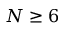Convert formula to latex. <formula><loc_0><loc_0><loc_500><loc_500>N \geq 6</formula> 